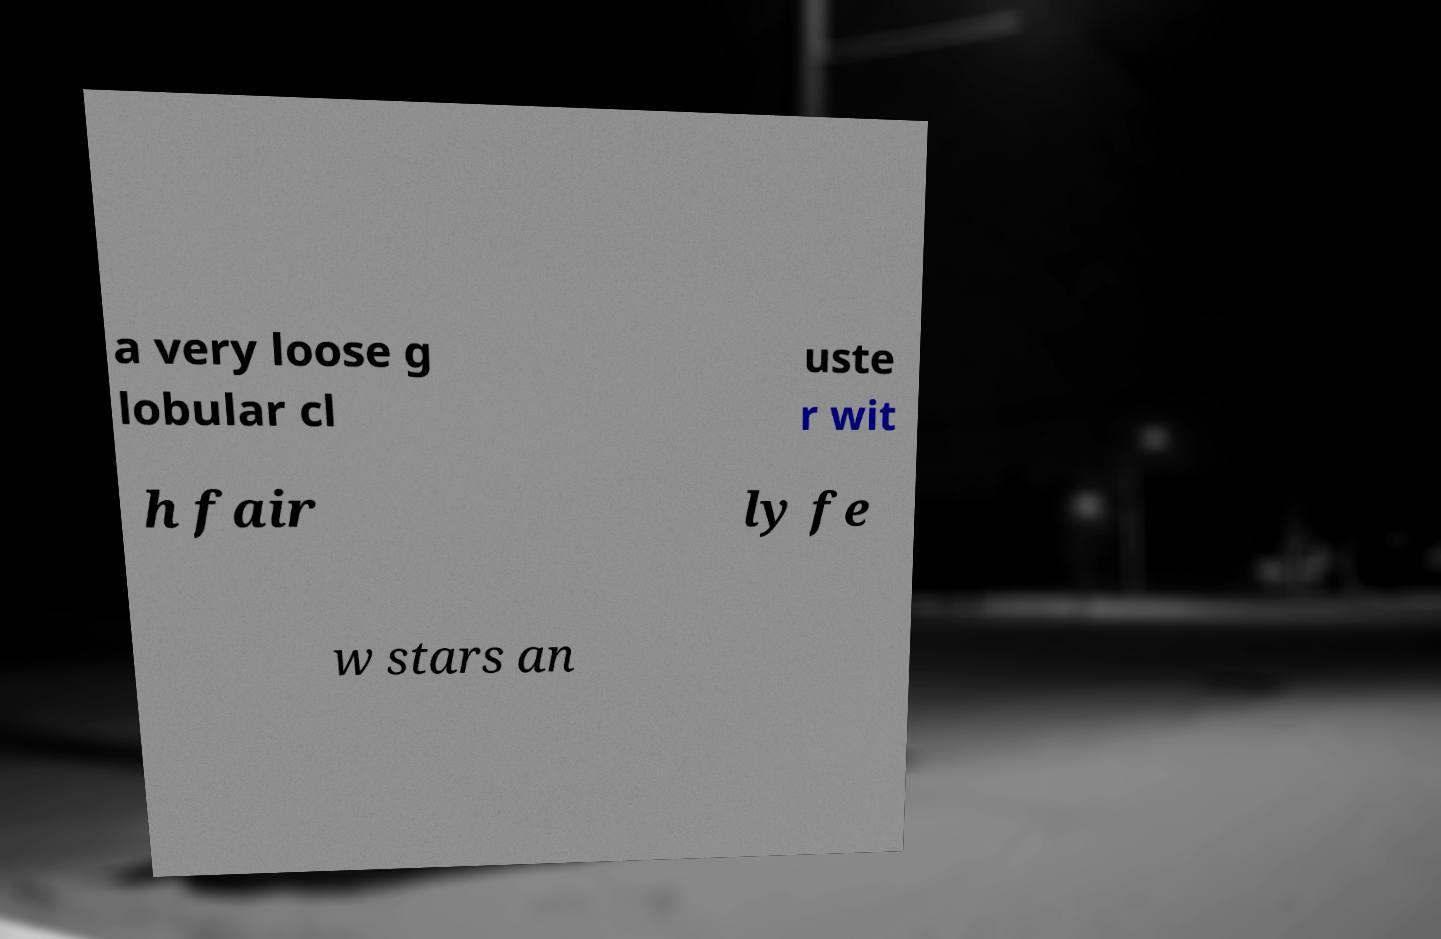Please read and relay the text visible in this image. What does it say? a very loose g lobular cl uste r wit h fair ly fe w stars an 